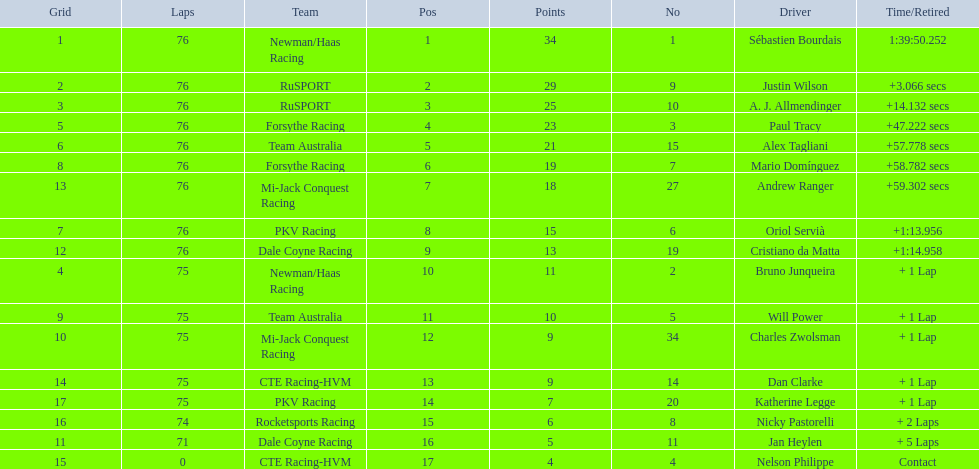Which drivers completed all 76 laps? Sébastien Bourdais, Justin Wilson, A. J. Allmendinger, Paul Tracy, Alex Tagliani, Mario Domínguez, Andrew Ranger, Oriol Servià, Cristiano da Matta. Of these drivers, which ones finished less than a minute behind first place? Paul Tracy, Alex Tagliani, Mario Domínguez, Andrew Ranger. Of these drivers, which ones finished with a time less than 50 seconds behind first place? Justin Wilson, A. J. Allmendinger, Paul Tracy. Of these three drivers, who finished last? Paul Tracy. 